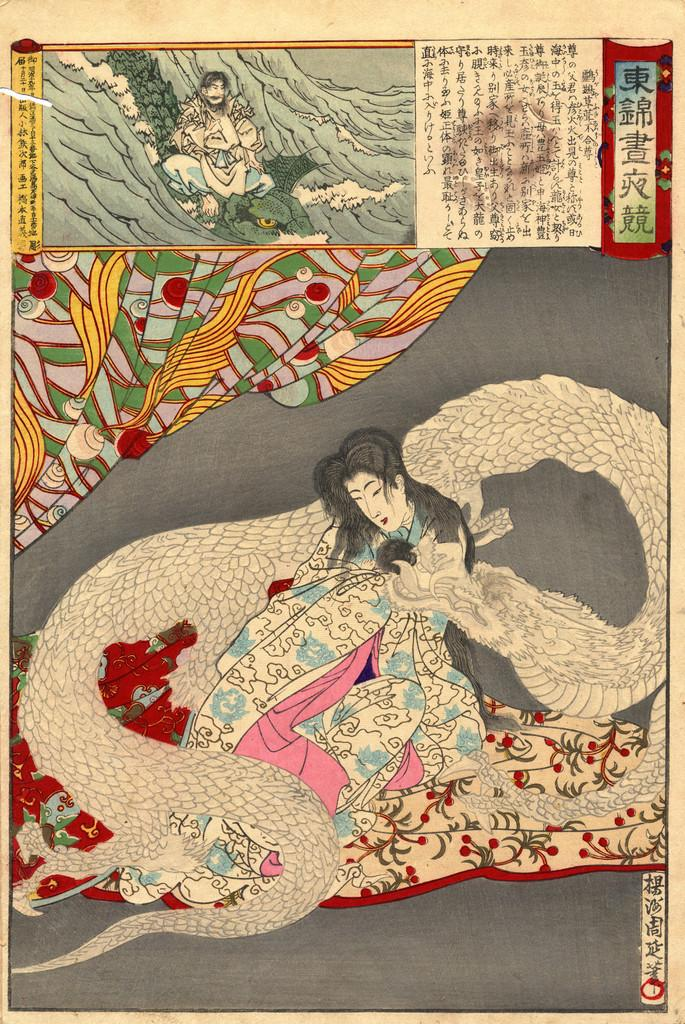What type of visual representation is shown in the image? The image is a poster. How many people are depicted on the poster? There are two people depicted on the poster. What kind of mythical creature is present on the poster? There is a dragon snake on the poster. What can be seen covering the bodies of the people on the poster? Clothes are visible on the poster. What else can be seen on the poster besides the people and the dragon snake? There are objects on the poster. Is there any text present on the poster? Yes, there is text on the poster. How many mice are running around the dragon snake on the poster? There are no mice present on the poster; it features a dragon snake, people, clothes, objects, and text. What type of light source is illuminating the poster? The image provided does not include any information about a light source, so it cannot be determined from the image. 